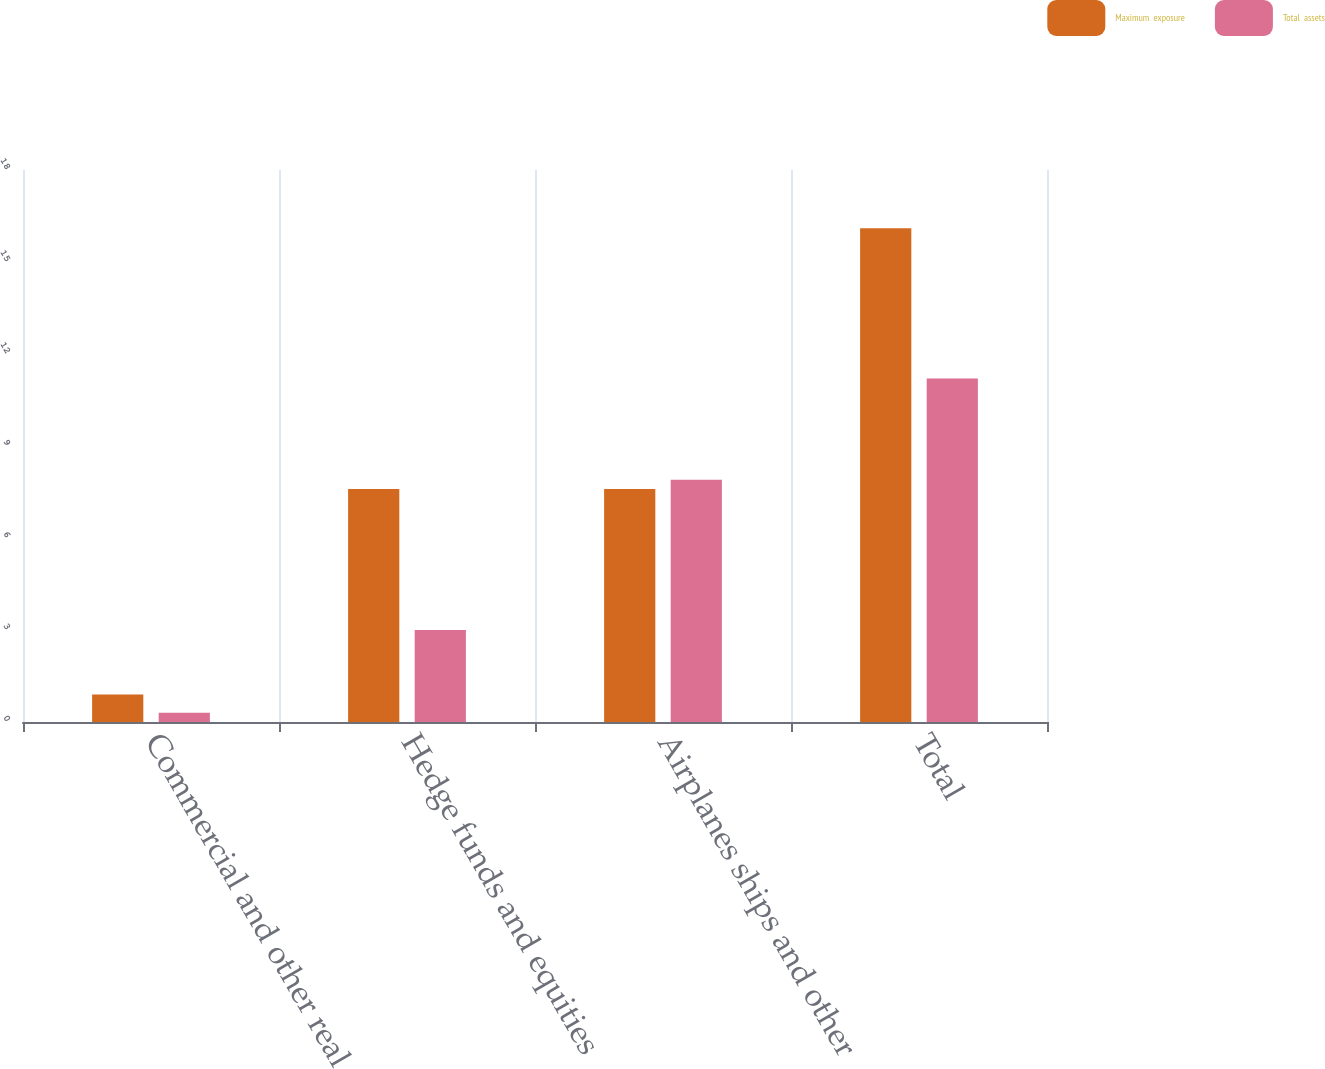Convert chart to OTSL. <chart><loc_0><loc_0><loc_500><loc_500><stacked_bar_chart><ecel><fcel>Commercial and other real<fcel>Hedge funds and equities<fcel>Airplanes ships and other<fcel>Total<nl><fcel>Maximum  exposure<fcel>0.9<fcel>7.6<fcel>7.6<fcel>16.1<nl><fcel>Total  assets<fcel>0.3<fcel>3<fcel>7.9<fcel>11.2<nl></chart> 